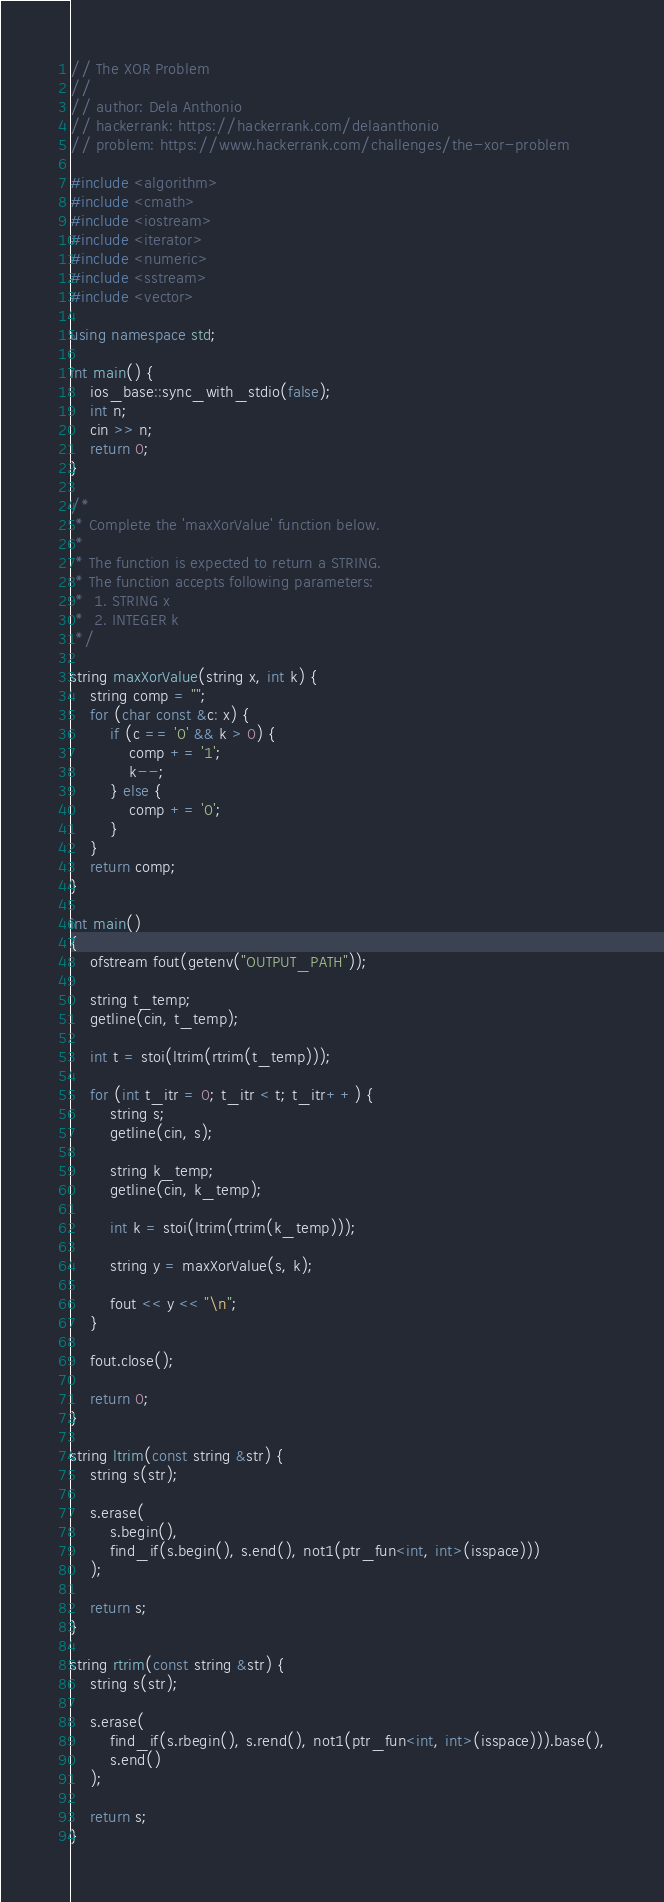Convert code to text. <code><loc_0><loc_0><loc_500><loc_500><_C++_>// The XOR Problem
//
// author: Dela Anthonio
// hackerrank: https://hackerrank.com/delaanthonio
// problem: https://www.hackerrank.com/challenges/the-xor-problem

#include <algorithm>
#include <cmath>
#include <iostream>
#include <iterator>
#include <numeric>
#include <sstream>
#include <vector>

using namespace std;

int main() {
    ios_base::sync_with_stdio(false);
    int n;
    cin >> n;
    return 0;
}

/*
 * Complete the 'maxXorValue' function below.
 *
 * The function is expected to return a STRING.
 * The function accepts following parameters:
 *  1. STRING x
 *  2. INTEGER k
 */

string maxXorValue(string x, int k) {
    string comp = "";
    for (char const &c: x) {
        if (c == '0' && k > 0) {
            comp += '1';
            k--;
        } else {
            comp += '0';
        }
    }
    return comp;
}

int main()
{
    ofstream fout(getenv("OUTPUT_PATH"));

    string t_temp;
    getline(cin, t_temp);

    int t = stoi(ltrim(rtrim(t_temp)));

    for (int t_itr = 0; t_itr < t; t_itr++) {
        string s;
        getline(cin, s);

        string k_temp;
        getline(cin, k_temp);

        int k = stoi(ltrim(rtrim(k_temp)));

        string y = maxXorValue(s, k);

        fout << y << "\n";
    }

    fout.close();

    return 0;
}

string ltrim(const string &str) {
    string s(str);

    s.erase(
        s.begin(),
        find_if(s.begin(), s.end(), not1(ptr_fun<int, int>(isspace)))
    );

    return s;
}

string rtrim(const string &str) {
    string s(str);

    s.erase(
        find_if(s.rbegin(), s.rend(), not1(ptr_fun<int, int>(isspace))).base(),
        s.end()
    );

    return s;
}

</code> 